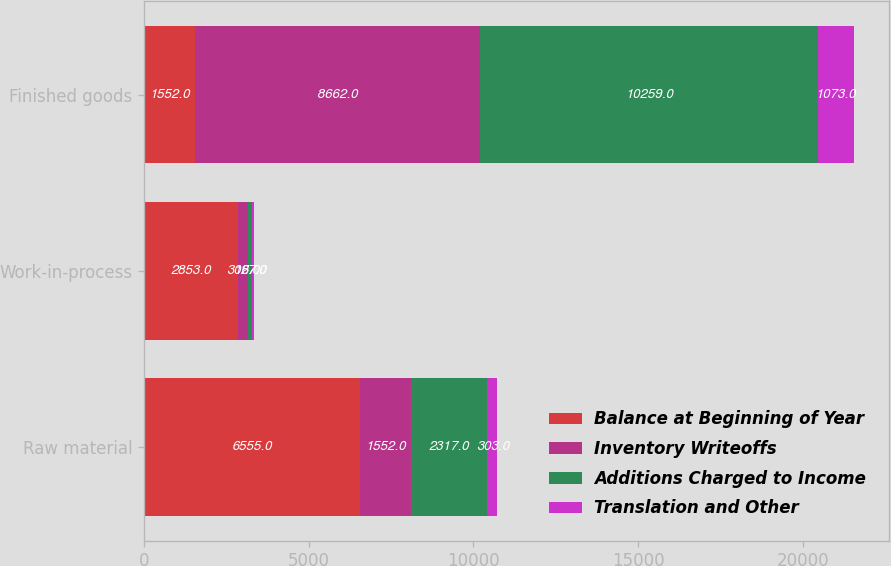<chart> <loc_0><loc_0><loc_500><loc_500><stacked_bar_chart><ecel><fcel>Raw material<fcel>Work-in-process<fcel>Finished goods<nl><fcel>Balance at Beginning of Year<fcel>6555<fcel>2853<fcel>1552<nl><fcel>Inventory Writeoffs<fcel>1552<fcel>306<fcel>8662<nl><fcel>Additions Charged to Income<fcel>2317<fcel>127<fcel>10259<nl><fcel>Translation and Other<fcel>303<fcel>57<fcel>1073<nl></chart> 